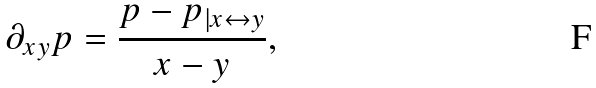<formula> <loc_0><loc_0><loc_500><loc_500>\partial _ { x y } p = \frac { p - p _ { | x \leftrightarrow y } } { x - y } ,</formula> 